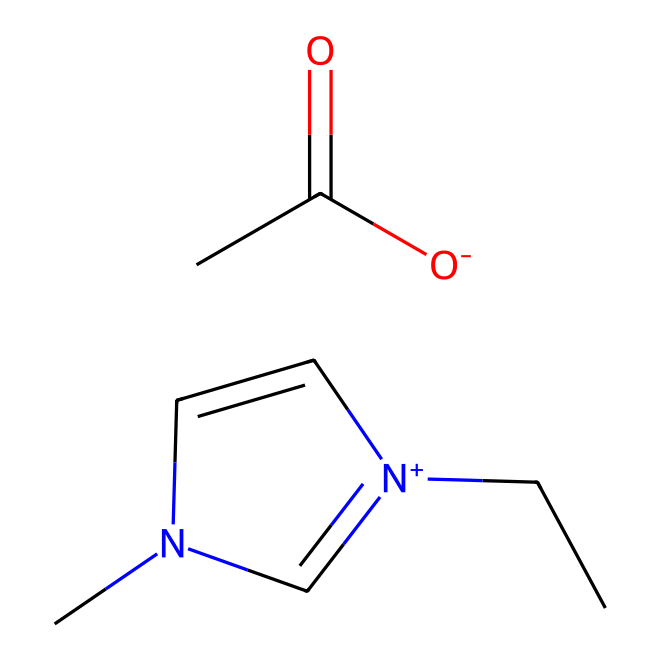How many nitrogen atoms are present in the structure? By examining the SMILES representation, we can identify that there are two nitrogen atoms represented by "n" and "[n+]" in the structure.
Answer: two What type of functional group is present in this ionic liquid? The presence of "CC(=O)[O-]" indicates a carboxylate ion (due to the -COO- structure). This functional group is characteristic of organic acids.
Answer: carboxylate What is the oxidation state of the nitrogen atom in the [n+] part of the structure? The "[n+]" indicates that the nitrogen has gained an extra proton or positive charge, which makes its oxidation state +1.
Answer: +1 How many carbon atoms are present in the structure? The structure includes the "CC" portion from the cation as well as the "CC" from the carboxylate, totaling four carbon atoms in the entire ionic liquid.
Answer: four What characteristic property of ionic liquids is suggested by the presence of charged species? The existence of [n+] and [O-] indicates the presence of charged particles that contribute to the ionicity and low volatility, which is a characteristic property of ionic liquids.
Answer: low volatility What type of interactions might this ionic liquid have due to its structure? The presence of charged functional groups suggests that this ionic liquid can engage in strong ionic and polar interactions, leading to its solubility in polar solvents and effectiveness in cleaning applications.
Answer: strong ionic interactions 